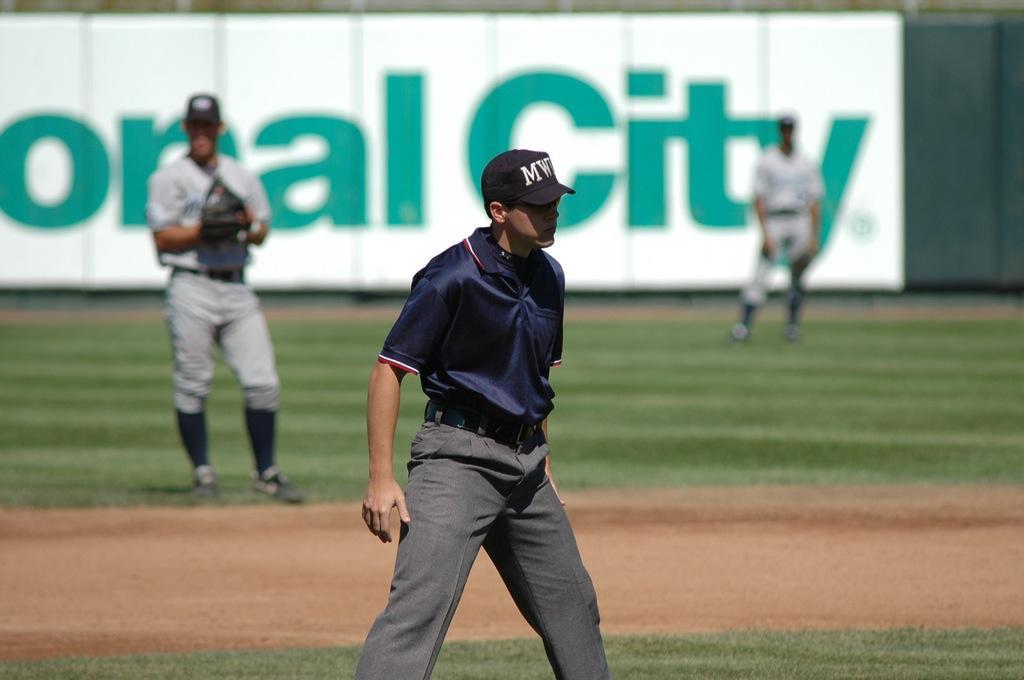Can you describe this image briefly? This is a playing ground. In this image I can see three men wearing sports dresses, caps on their heads and standing. On the ground, I can see the grass. In the background there is a white color board on which I can see some text. 